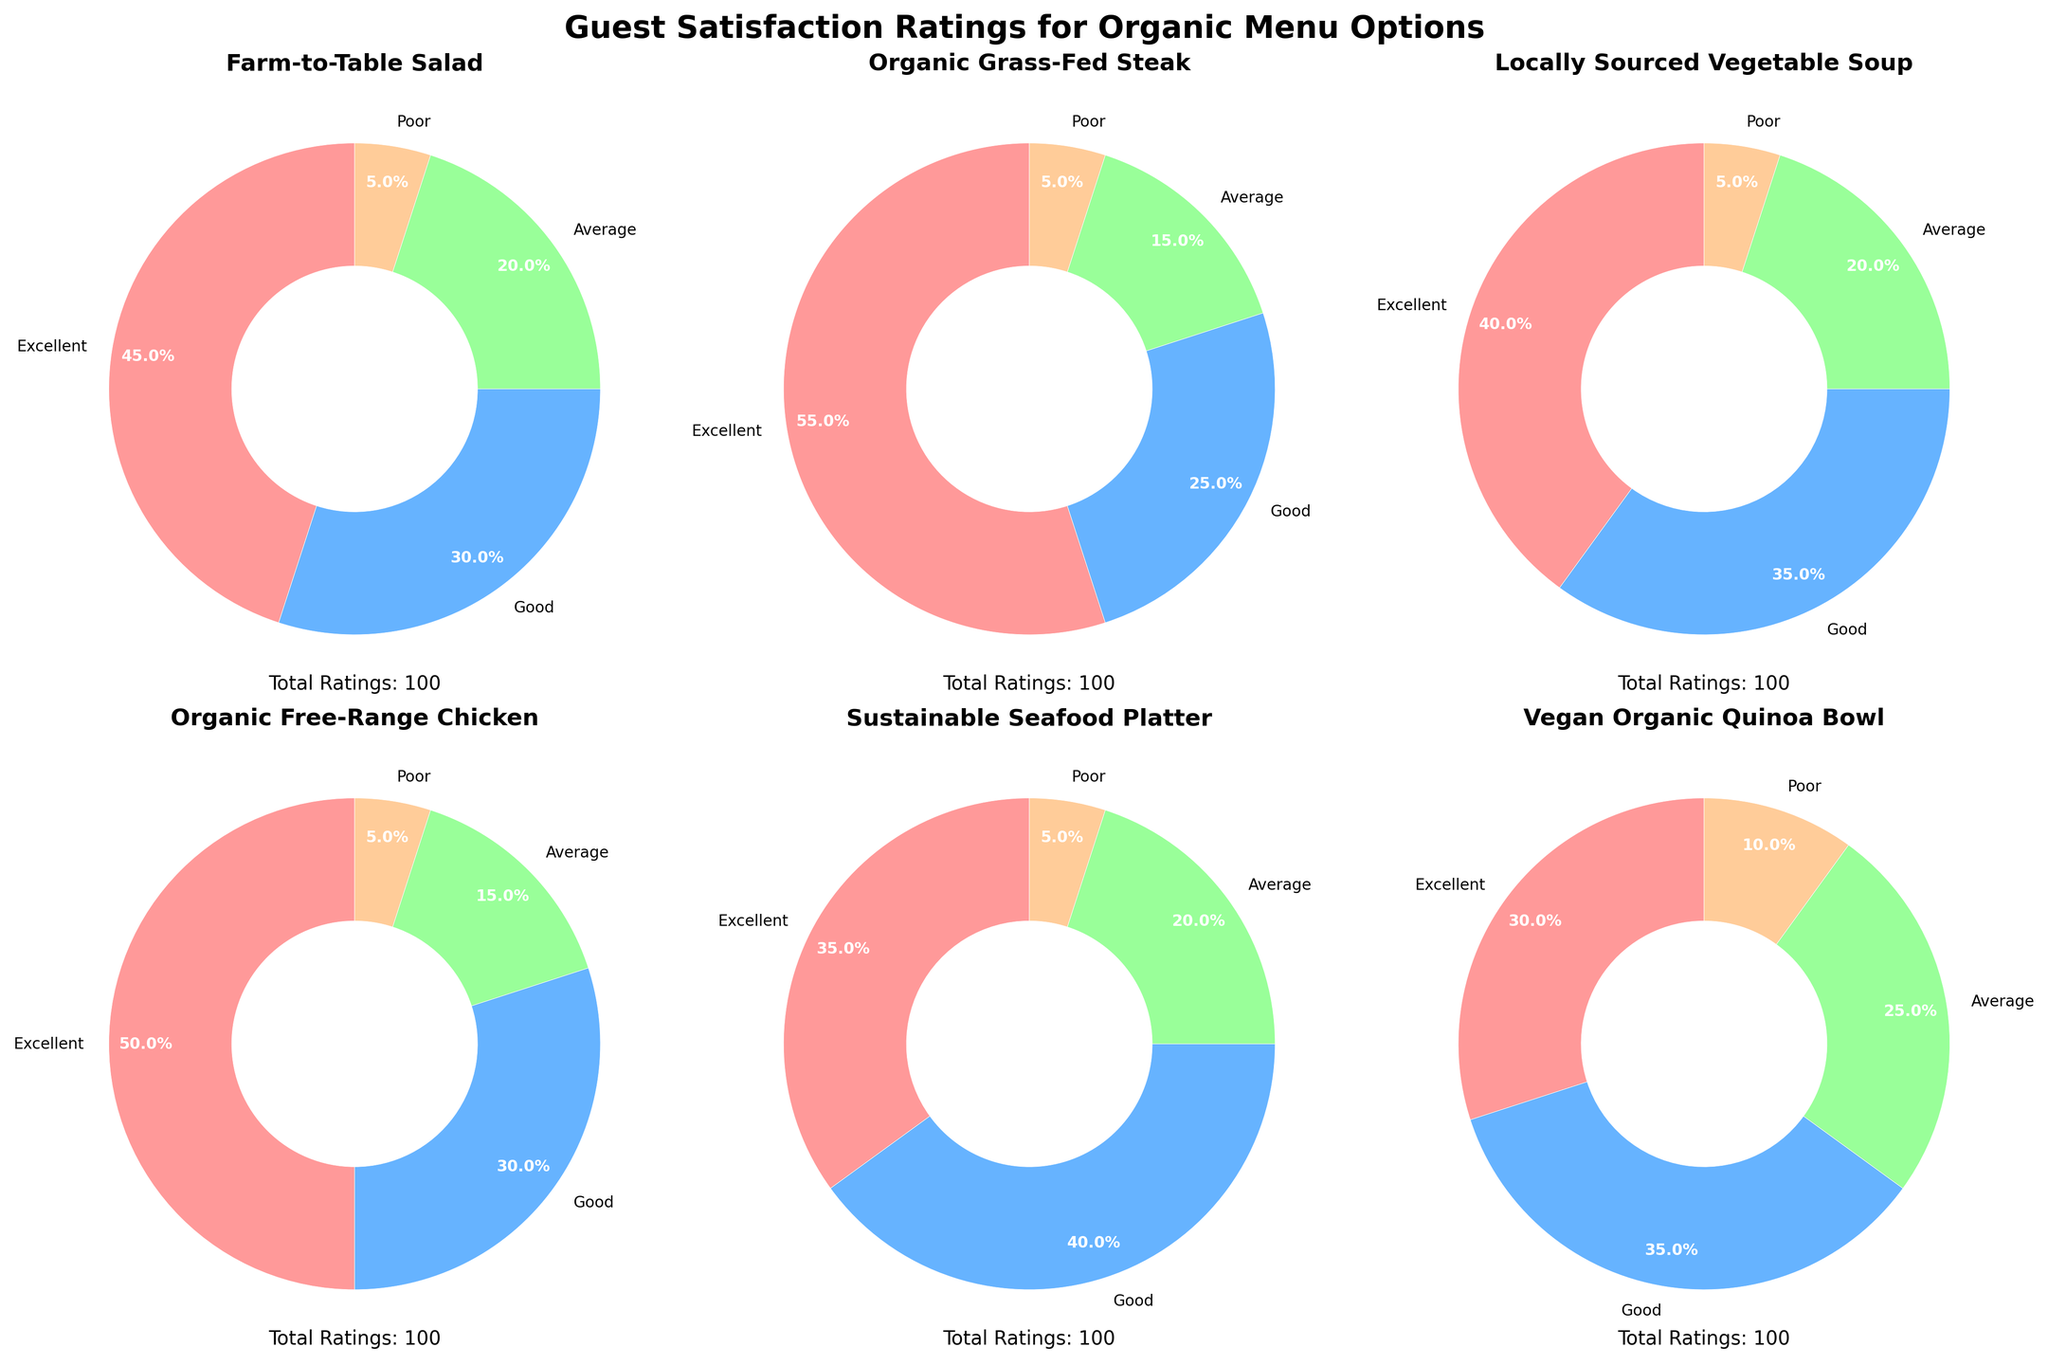How many menu options are analyzed in the chart? Each pie chart represents a different menu option, and there are 6 pie charts in total arranged in a 2x3 grid.
Answer: 6 Which menu option received the highest percentage of 'Excellent' ratings? By inspecting each pie chart, the 'Organic Grass-Fed Steak' has the highest percentage of 'Excellent' ratings at 55%.
Answer: Organic Grass-Fed Steak Which menu option has the least percentage of 'Poor' ratings? All menu options have an exact 5% 'Poor' rating as indicated in the pie charts.
Answer: All menu options What is the total number of ratings for the Vegan Organic Quinoa Bowl? The pie chart for the Vegan Organic Quinoa Bowl lists total ratings, summing up the sections: 30 (Excellent) + 35 (Good) + 25 (Average) + 10 (Poor) = 100 ratings.
Answer: 100 Among the sustainable seafood platter and the organic free-range chicken, which received a higher percentage of 'Good' ratings? The pie chart shows 40% 'Good' ratings for the Sustainable Seafood Platter and 30% for the Organic Free-Range Chicken, making the Sustainable Seafood Platter higher.
Answer: Sustainable Seafood Platter Which aspect (Excellent, Good, Average, or Poor) has the most variation across all menu options? By comparing pie chart slices, the 'Excellent' rating shows the most strategic variation, ranging from 30% to 55%.
Answer: Excellent What percentage of total ratings for the Farm-to-Table Salad were 'Average' or 'Poor'? By summing up the percentages of 'Average' and 'Poor' ratings for the Farm-to-Table Salad: 20% (Average) + 5% (Poor) = 25%.
Answer: 25% Calculate the average percentage of 'Good' ratings across all menu options. Add the percentages of 'Good' ratings for all menu options and divide by the number of options: (30 + 25 + 35 + 30 + 40 + 35) / 6 = 32.5%.
Answer: 32.5 Which menu option has the largest total ratings, and what is that total? Each chart shows the total ratings text below it. By comparing, all options show 100 total ratings; hence there is no largest.
Answer: All options, 100 What percentage of total ratings were 'Excellent' for the Organic Free-Range Chicken and the Vegan Organic Quinoa Bowl combined? For Organic Free-Range Chicken: 50% ('Excellent') of 100 ratings = 50. For Vegan Organic Quinoa Bowl: 30% ('Excellent') of 100 ratings = 30. Combined: (50 + 30) / (100 + 100) * 100 = 40%.
Answer: 40% 